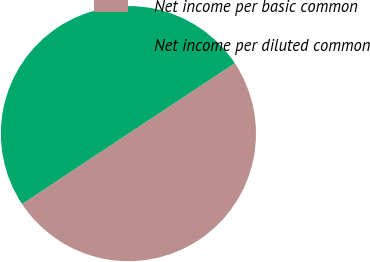<chart> <loc_0><loc_0><loc_500><loc_500><pie_chart><fcel>Net income per basic common<fcel>Net income per diluted common<nl><fcel>50.0%<fcel>50.0%<nl></chart> 